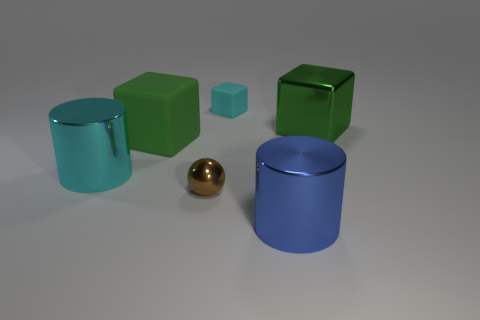Add 2 cyan shiny things. How many objects exist? 8 Subtract all spheres. How many objects are left? 5 Subtract 0 red balls. How many objects are left? 6 Subtract all green objects. Subtract all large cubes. How many objects are left? 2 Add 5 brown things. How many brown things are left? 6 Add 1 cyan shiny balls. How many cyan shiny balls exist? 1 